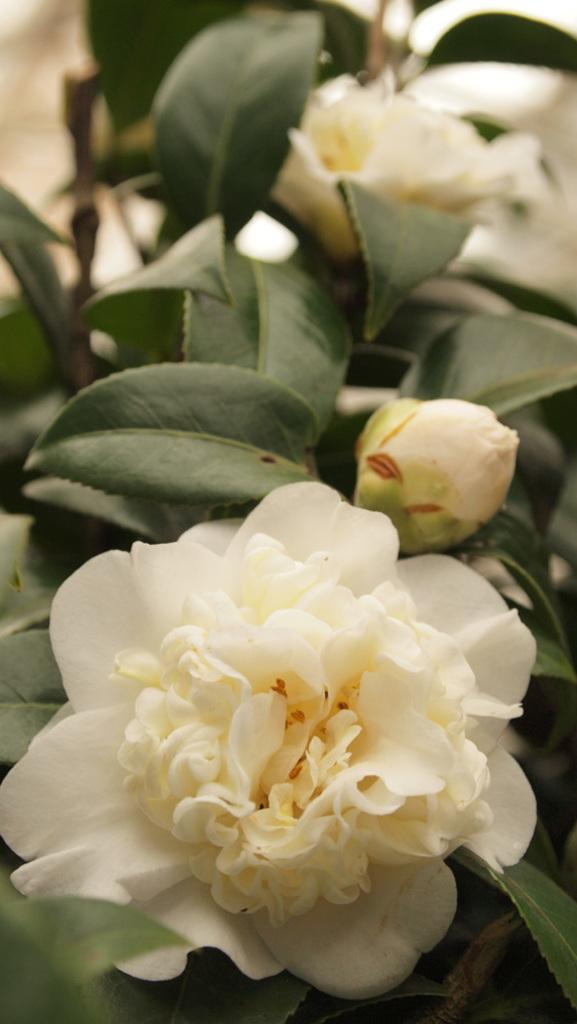What type of living organisms are present in the image? The image contains plants. What specific features can be observed on the plants? The plants have flowers and a bud. What color are the flowers in the image? The flowers are white in color. How would you describe the background of the image? The background of the image is blurred. What type of game is being played in the image? There is no game present in the image; it features plants with white flowers and a blurred background. Can you tell me how many matches are visible in the image? There are no matches present in the image. 